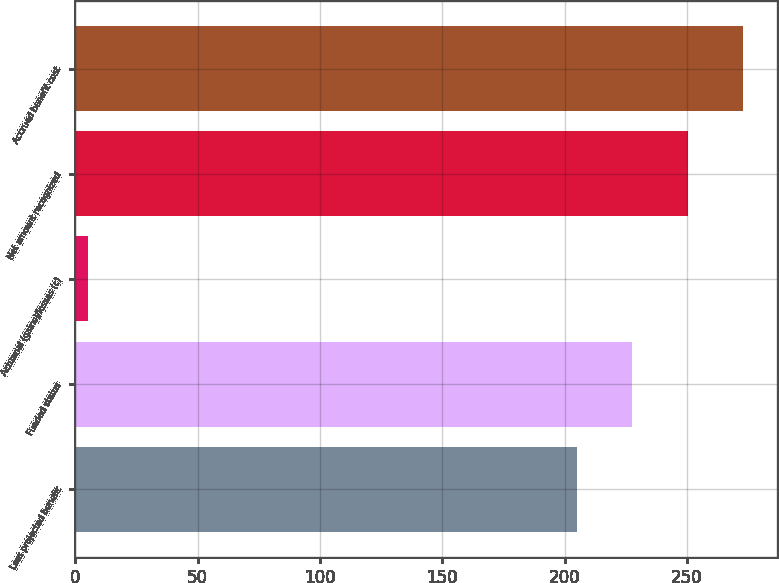Convert chart. <chart><loc_0><loc_0><loc_500><loc_500><bar_chart><fcel>Less projected benefit<fcel>Funded status<fcel>Actuarial (gains)/losses (c)<fcel>Net amount recognized<fcel>Accrued benefit cost<nl><fcel>205<fcel>227.7<fcel>5<fcel>250.4<fcel>273.1<nl></chart> 